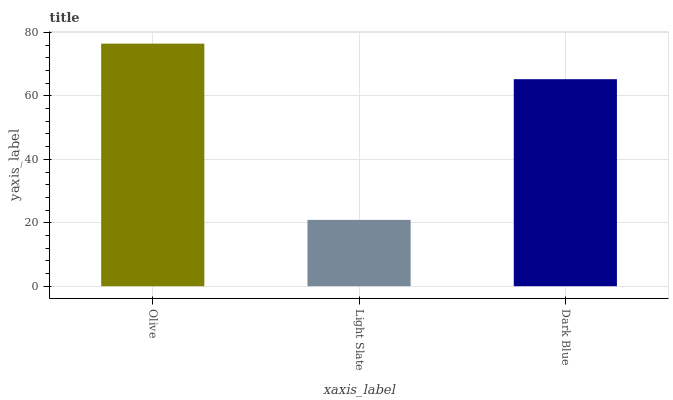Is Dark Blue the minimum?
Answer yes or no. No. Is Dark Blue the maximum?
Answer yes or no. No. Is Dark Blue greater than Light Slate?
Answer yes or no. Yes. Is Light Slate less than Dark Blue?
Answer yes or no. Yes. Is Light Slate greater than Dark Blue?
Answer yes or no. No. Is Dark Blue less than Light Slate?
Answer yes or no. No. Is Dark Blue the high median?
Answer yes or no. Yes. Is Dark Blue the low median?
Answer yes or no. Yes. Is Olive the high median?
Answer yes or no. No. Is Light Slate the low median?
Answer yes or no. No. 